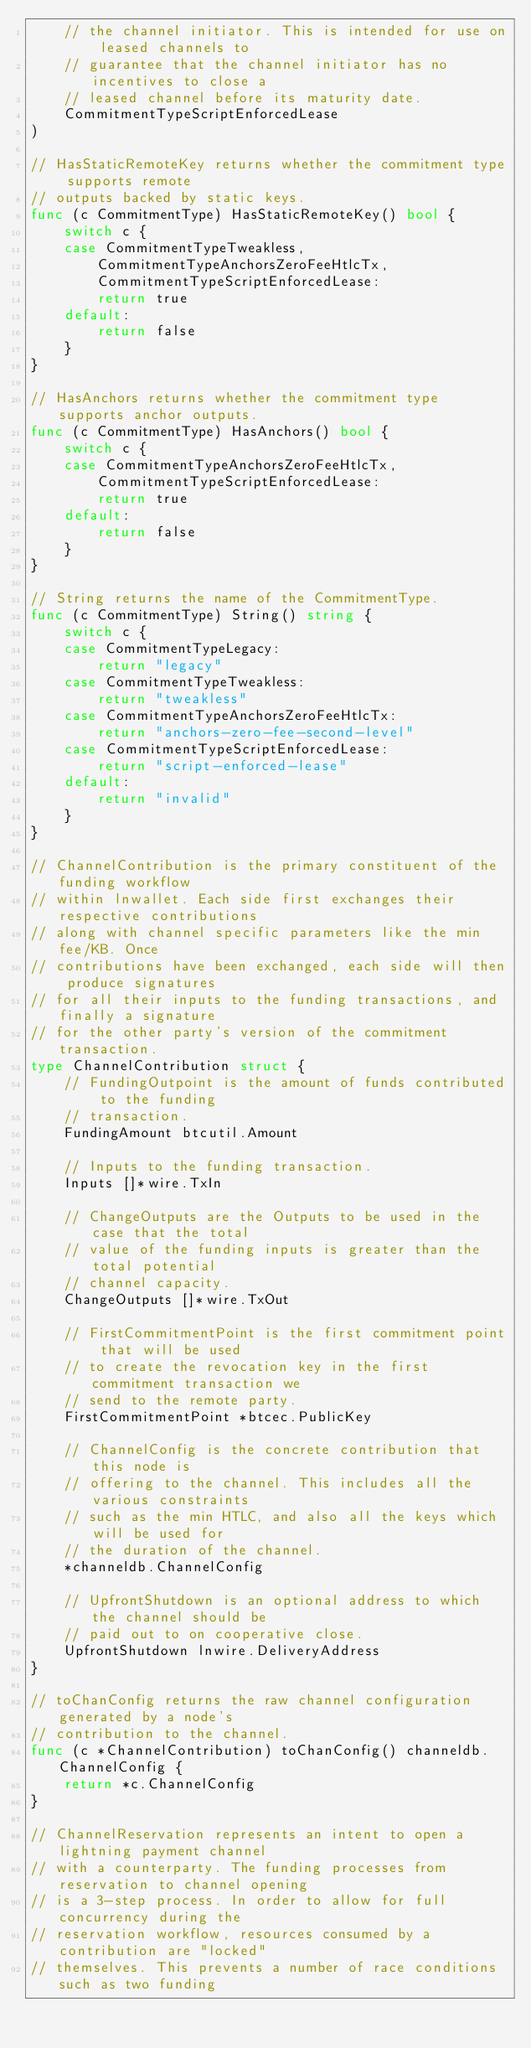Convert code to text. <code><loc_0><loc_0><loc_500><loc_500><_Go_>	// the channel initiator. This is intended for use on leased channels to
	// guarantee that the channel initiator has no incentives to close a
	// leased channel before its maturity date.
	CommitmentTypeScriptEnforcedLease
)

// HasStaticRemoteKey returns whether the commitment type supports remote
// outputs backed by static keys.
func (c CommitmentType) HasStaticRemoteKey() bool {
	switch c {
	case CommitmentTypeTweakless,
		CommitmentTypeAnchorsZeroFeeHtlcTx,
		CommitmentTypeScriptEnforcedLease:
		return true
	default:
		return false
	}
}

// HasAnchors returns whether the commitment type supports anchor outputs.
func (c CommitmentType) HasAnchors() bool {
	switch c {
	case CommitmentTypeAnchorsZeroFeeHtlcTx,
		CommitmentTypeScriptEnforcedLease:
		return true
	default:
		return false
	}
}

// String returns the name of the CommitmentType.
func (c CommitmentType) String() string {
	switch c {
	case CommitmentTypeLegacy:
		return "legacy"
	case CommitmentTypeTweakless:
		return "tweakless"
	case CommitmentTypeAnchorsZeroFeeHtlcTx:
		return "anchors-zero-fee-second-level"
	case CommitmentTypeScriptEnforcedLease:
		return "script-enforced-lease"
	default:
		return "invalid"
	}
}

// ChannelContribution is the primary constituent of the funding workflow
// within lnwallet. Each side first exchanges their respective contributions
// along with channel specific parameters like the min fee/KB. Once
// contributions have been exchanged, each side will then produce signatures
// for all their inputs to the funding transactions, and finally a signature
// for the other party's version of the commitment transaction.
type ChannelContribution struct {
	// FundingOutpoint is the amount of funds contributed to the funding
	// transaction.
	FundingAmount btcutil.Amount

	// Inputs to the funding transaction.
	Inputs []*wire.TxIn

	// ChangeOutputs are the Outputs to be used in the case that the total
	// value of the funding inputs is greater than the total potential
	// channel capacity.
	ChangeOutputs []*wire.TxOut

	// FirstCommitmentPoint is the first commitment point that will be used
	// to create the revocation key in the first commitment transaction we
	// send to the remote party.
	FirstCommitmentPoint *btcec.PublicKey

	// ChannelConfig is the concrete contribution that this node is
	// offering to the channel. This includes all the various constraints
	// such as the min HTLC, and also all the keys which will be used for
	// the duration of the channel.
	*channeldb.ChannelConfig

	// UpfrontShutdown is an optional address to which the channel should be
	// paid out to on cooperative close.
	UpfrontShutdown lnwire.DeliveryAddress
}

// toChanConfig returns the raw channel configuration generated by a node's
// contribution to the channel.
func (c *ChannelContribution) toChanConfig() channeldb.ChannelConfig {
	return *c.ChannelConfig
}

// ChannelReservation represents an intent to open a lightning payment channel
// with a counterparty. The funding processes from reservation to channel opening
// is a 3-step process. In order to allow for full concurrency during the
// reservation workflow, resources consumed by a contribution are "locked"
// themselves. This prevents a number of race conditions such as two funding</code> 